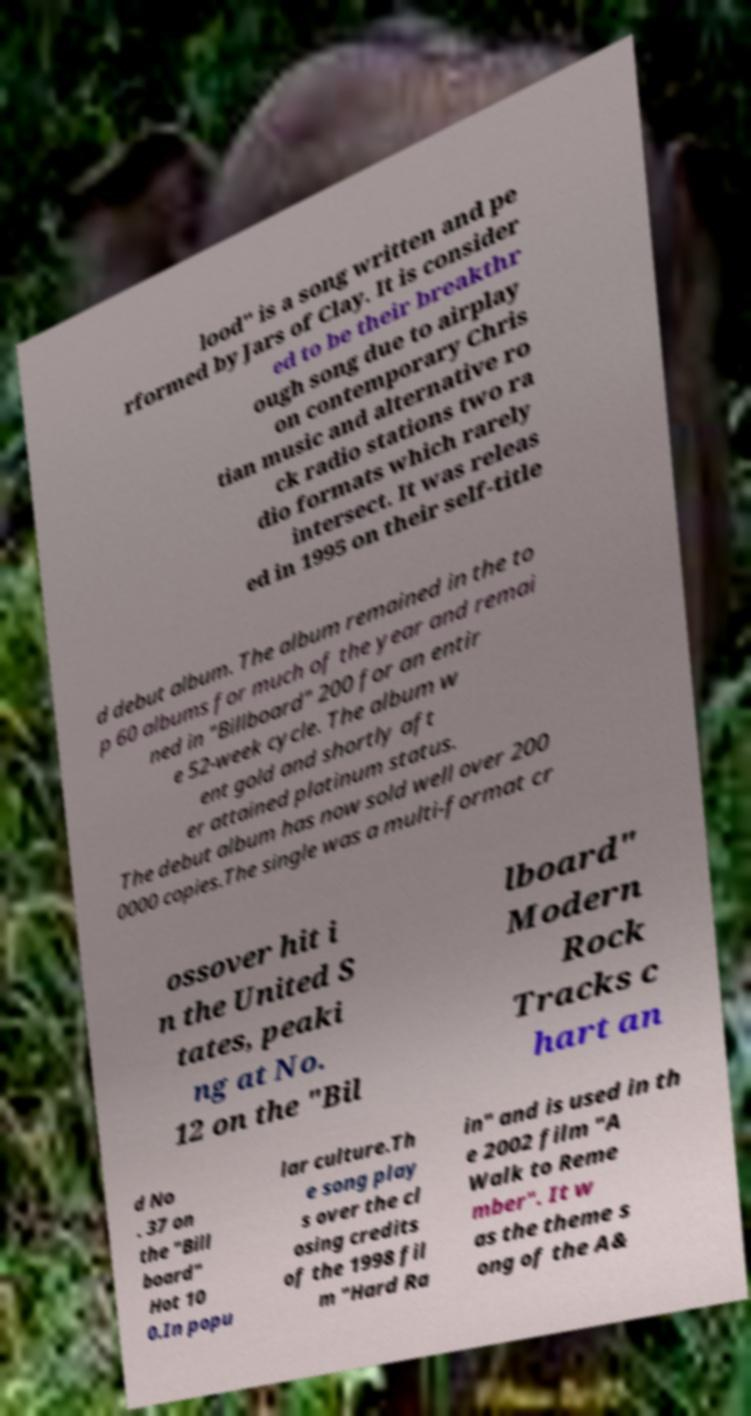Can you read and provide the text displayed in the image?This photo seems to have some interesting text. Can you extract and type it out for me? lood" is a song written and pe rformed by Jars of Clay. It is consider ed to be their breakthr ough song due to airplay on contemporary Chris tian music and alternative ro ck radio stations two ra dio formats which rarely intersect. It was releas ed in 1995 on their self-title d debut album. The album remained in the to p 60 albums for much of the year and remai ned in "Billboard" 200 for an entir e 52-week cycle. The album w ent gold and shortly aft er attained platinum status. The debut album has now sold well over 200 0000 copies.The single was a multi-format cr ossover hit i n the United S tates, peaki ng at No. 12 on the "Bil lboard" Modern Rock Tracks c hart an d No . 37 on the "Bill board" Hot 10 0.In popu lar culture.Th e song play s over the cl osing credits of the 1998 fil m "Hard Ra in" and is used in th e 2002 film "A Walk to Reme mber". It w as the theme s ong of the A& 